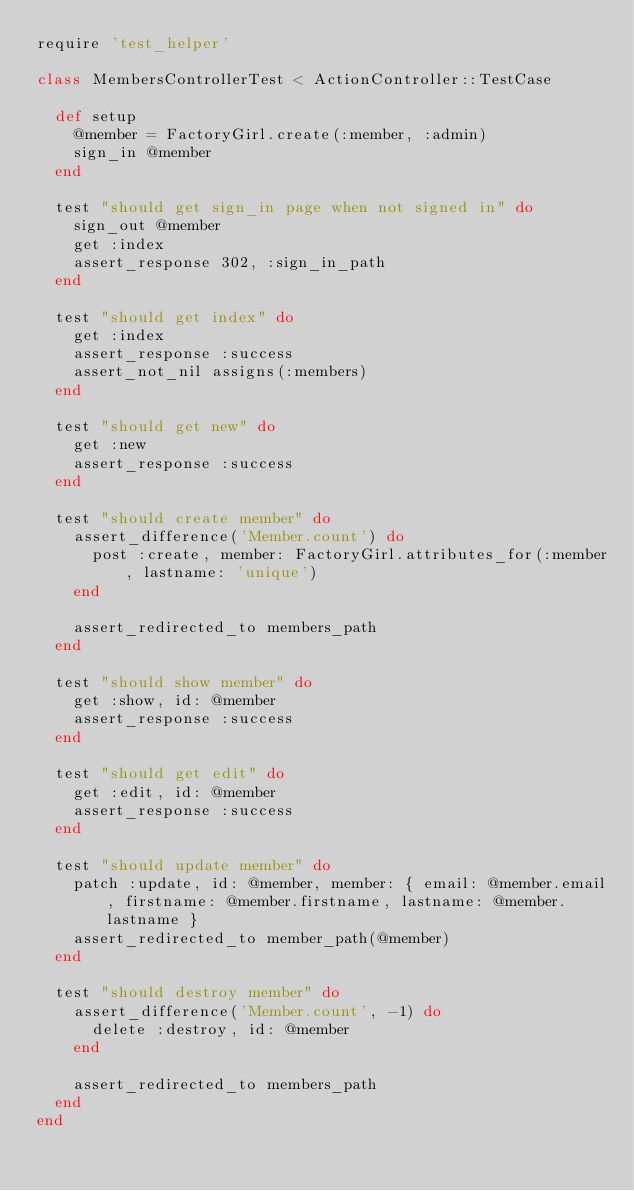<code> <loc_0><loc_0><loc_500><loc_500><_Ruby_>require 'test_helper'

class MembersControllerTest < ActionController::TestCase

  def setup
    @member = FactoryGirl.create(:member, :admin)
    sign_in @member
  end

  test "should get sign_in page when not signed in" do
    sign_out @member
    get :index
    assert_response 302, :sign_in_path
  end

  test "should get index" do
    get :index
    assert_response :success
    assert_not_nil assigns(:members)
  end

  test "should get new" do
    get :new
    assert_response :success
  end

  test "should create member" do
    assert_difference('Member.count') do
      post :create, member: FactoryGirl.attributes_for(:member, lastname: 'unique')
    end

    assert_redirected_to members_path
  end

  test "should show member" do
    get :show, id: @member
    assert_response :success
  end

  test "should get edit" do
    get :edit, id: @member
    assert_response :success
  end

  test "should update member" do
    patch :update, id: @member, member: { email: @member.email, firstname: @member.firstname, lastname: @member.lastname }
    assert_redirected_to member_path(@member)
  end

  test "should destroy member" do
    assert_difference('Member.count', -1) do
      delete :destroy, id: @member
    end

    assert_redirected_to members_path
  end
end
</code> 